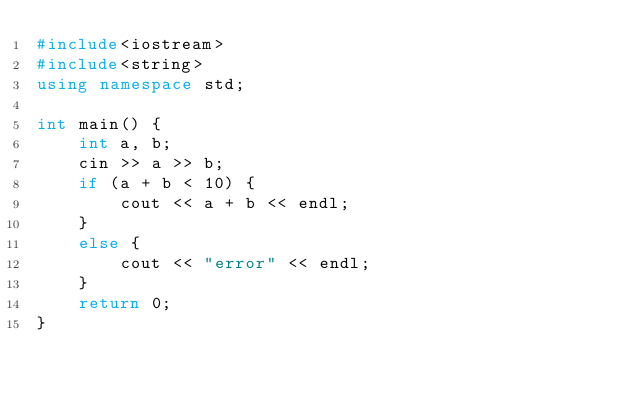Convert code to text. <code><loc_0><loc_0><loc_500><loc_500><_C++_>#include<iostream>
#include<string>
using namespace std;

int main() {
	int a, b;
	cin >> a >> b;
	if (a + b < 10) {
		cout << a + b << endl;
	}
	else {
		cout << "error" << endl;
	}
	return 0;
}</code> 